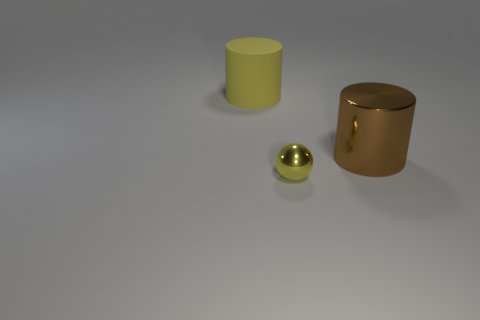Add 3 large brown metallic cylinders. How many objects exist? 6 Subtract all cylinders. How many objects are left? 1 Subtract 0 green spheres. How many objects are left? 3 Subtract all yellow cylinders. Subtract all shiny objects. How many objects are left? 0 Add 1 metallic cylinders. How many metallic cylinders are left? 2 Add 1 green metallic objects. How many green metallic objects exist? 1 